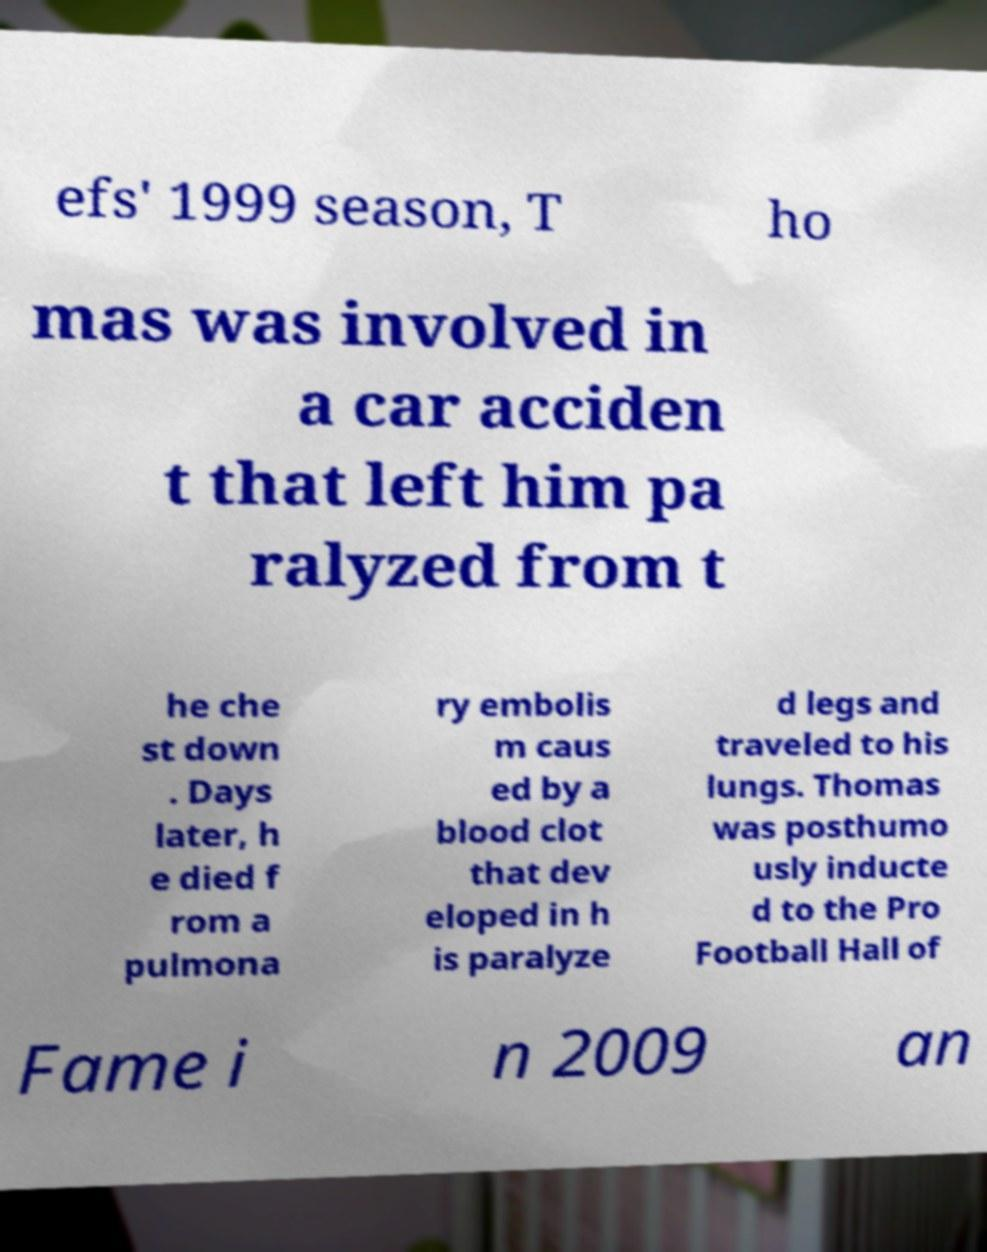Can you read and provide the text displayed in the image?This photo seems to have some interesting text. Can you extract and type it out for me? efs' 1999 season, T ho mas was involved in a car acciden t that left him pa ralyzed from t he che st down . Days later, h e died f rom a pulmona ry embolis m caus ed by a blood clot that dev eloped in h is paralyze d legs and traveled to his lungs. Thomas was posthumo usly inducte d to the Pro Football Hall of Fame i n 2009 an 